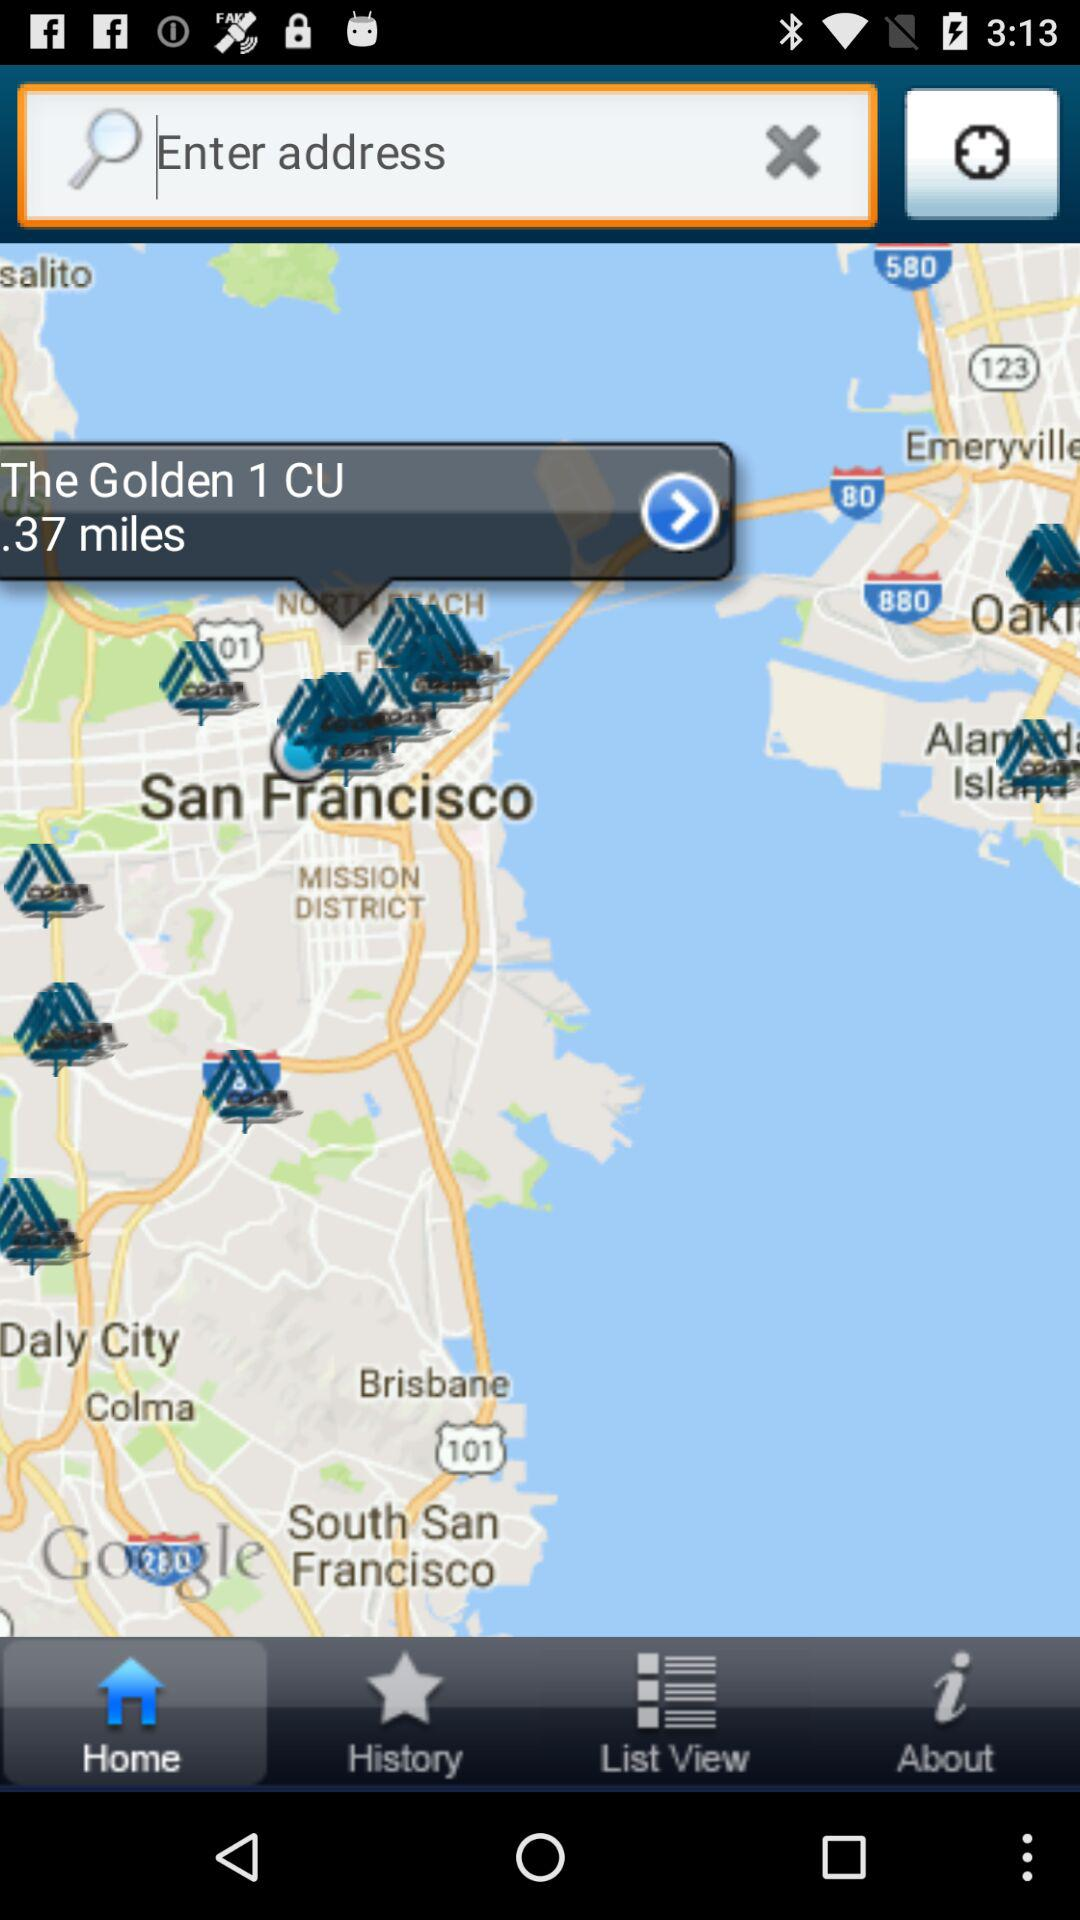How far is The Golden 1 CU from the user's location?
Answer the question using a single word or phrase. .37 miles 